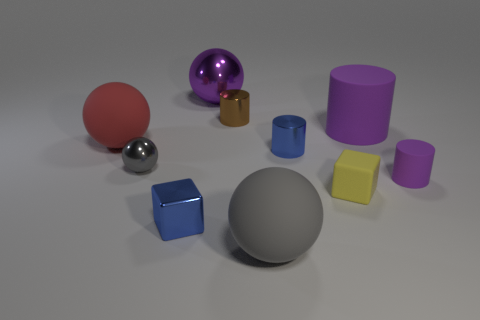Subtract 1 balls. How many balls are left? 3 Subtract all spheres. How many objects are left? 6 Subtract 0 cyan blocks. How many objects are left? 10 Subtract all red rubber things. Subtract all large purple metallic spheres. How many objects are left? 8 Add 4 blue objects. How many blue objects are left? 6 Add 4 tiny green rubber balls. How many tiny green rubber balls exist? 4 